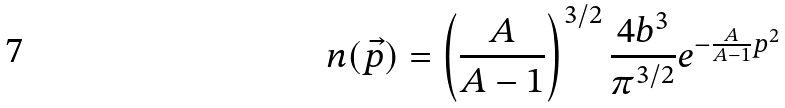<formula> <loc_0><loc_0><loc_500><loc_500>n ( \vec { p } ) = \left ( \frac { A } { A - 1 } \right ) ^ { 3 / 2 } \frac { 4 b ^ { 3 } } { \pi ^ { 3 / 2 } } e ^ { - \frac { A } { A - 1 } p ^ { 2 } }</formula> 